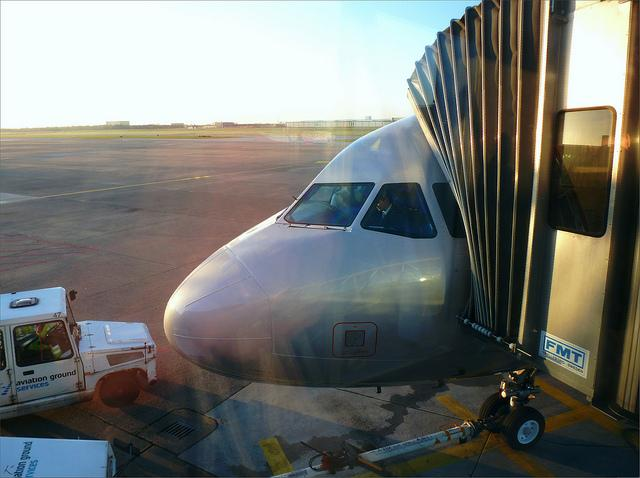What is this part of the plane known as? cockpit 